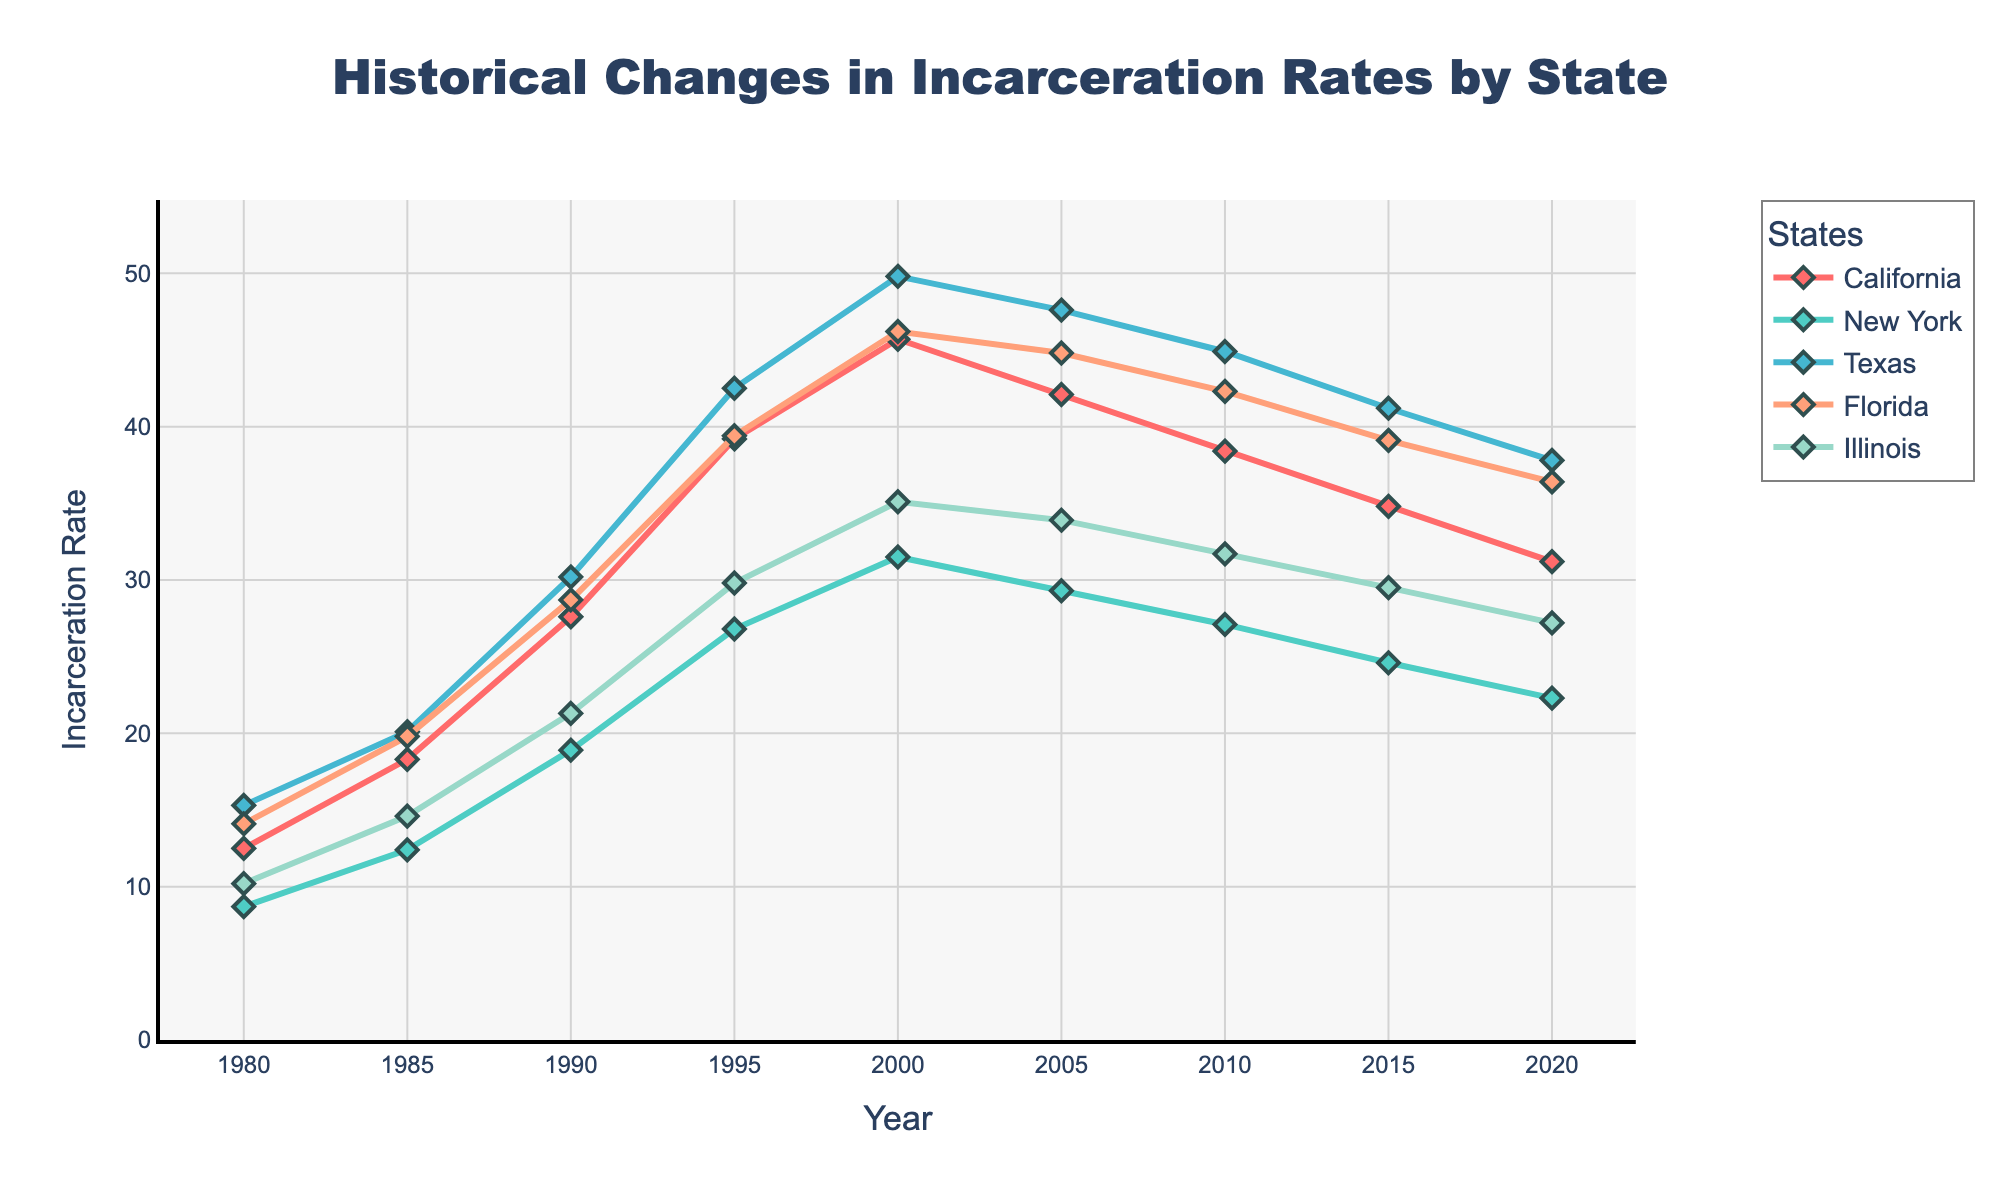What's the overall trend in incarceration rates for California from 1980 to 2020? To identify the trend, examine the general direction of the data points for California from 1980 to 2020. The line starts at 12.5 in 1980, peaks at 45.7 in 2000, and then declines to 31.2 in 2020. The overall trend shows an increase followed by a gradual decline.
Answer: Increase followed by a decline Which state had the highest incarceration rate in 1995? In 1995, compare the incarceration rates of all states: California (39.2), New York (26.8), Texas (42.5), Florida (39.4), Illinois (29.8). Texas has the highest rate with 42.5.
Answer: Texas By how much did the incarceration rate change in Florida between 1985 and 2000? To determine the change, subtract the 1985 value (19.8) from the 2000 value (46.2). The change is 46.2 - 19.8 = 26.4.
Answer: 26.4 Which state shows a consistent decrease in incarceration rates from 2000 to 2020? Observe the trends from 2000 to 2020 for all states. California decreased from 45.7 to 31.2, New York from 31.5 to 22.3, Texas from 49.8 to 37.8, Florida from 46.2 to 36.4, Illinois from 35.1 to 27.2. New York is the state with the most consistent decrease.
Answer: New York In which year did Illinois have its peak incarceration rate according to the data? Identify the highest data point for Illinois across the years. The peak value is 35.1 in 2000.
Answer: 2000 Compare the incarceration rates between Texas and Florida in 2020. Which state had a lower rate and by how much? In 2020, Texas' rate is 37.8 and Florida's is 36.4. Subtract Florida's rate from Texas', 37.8 - 36.4 = 1.4. Florida has a lower rate by 1.4.
Answer: Florida by 1.4 What's the average increase in incarceration rates for New York from 1980 to 1995? Calculate the difference for years 1985-1980, 1990-1985, and 1995-1990, then average them. (12.4-8.7=3.7; 18.9-12.4=6.5; 26.8-18.9=7.9). The average is (3.7 + 6.5 + 7.9)/3 = 6.03.
Answer: 6.03 Which state had the most significant decline in incarceration rates between 2000 and 2020? Calculate the decline for each state between 2000 and 2020. California: 45.7-31.2=14.5, New York: 31.5-22.3=9.2, Texas: 49.8-37.8=12, Florida: 46.2-36.4=9.8, Illinois: 35.1-27.2=7.9. California has the most significant decline at 14.5.
Answer: California 